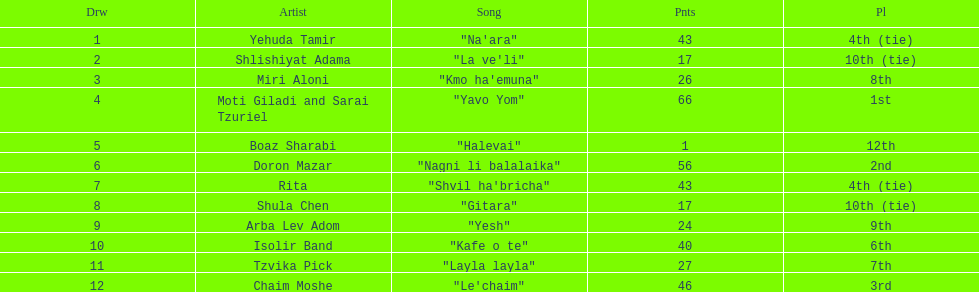What is the name of the foremost track listed on this chart? "Na'ara". 